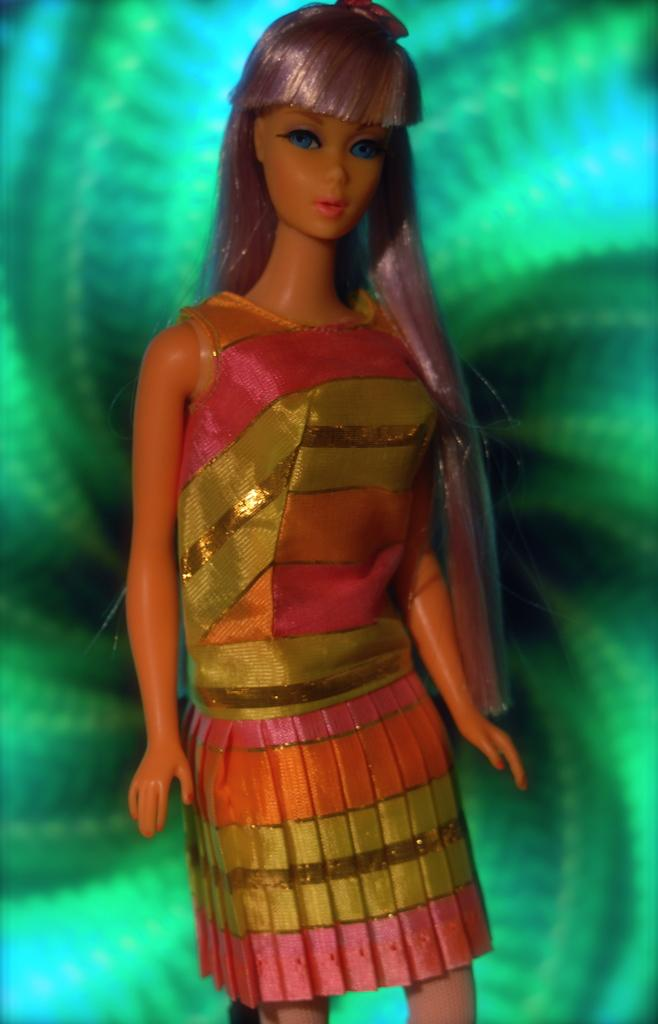What is the main subject in the image? There is a doll in the image. What color is the background of the image? The background of the image is green. What type of ring can be seen on the doll's finger in the image? There is no ring visible on the doll's finger in the image. What attraction is the doll visiting in the image? The image does not show the doll visiting any attraction. 